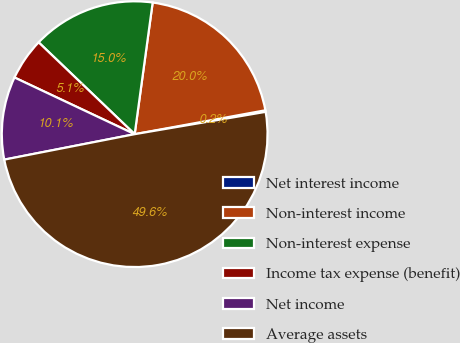<chart> <loc_0><loc_0><loc_500><loc_500><pie_chart><fcel>Net interest income<fcel>Non-interest income<fcel>Non-interest expense<fcel>Income tax expense (benefit)<fcel>Net income<fcel>Average assets<nl><fcel>0.19%<fcel>19.96%<fcel>15.02%<fcel>5.13%<fcel>10.08%<fcel>49.62%<nl></chart> 